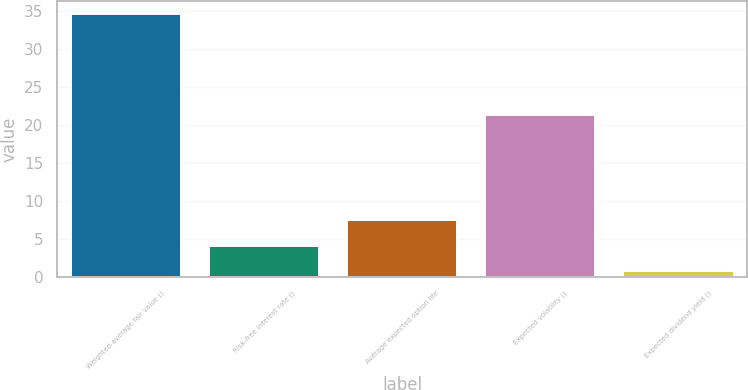<chart> <loc_0><loc_0><loc_500><loc_500><bar_chart><fcel>Weighted-average fair value ()<fcel>Risk-free interest rate ()<fcel>Average expected option life<fcel>Expected volatility ()<fcel>Expected dividend yield ()<nl><fcel>34.57<fcel>4.09<fcel>7.48<fcel>21.35<fcel>0.7<nl></chart> 